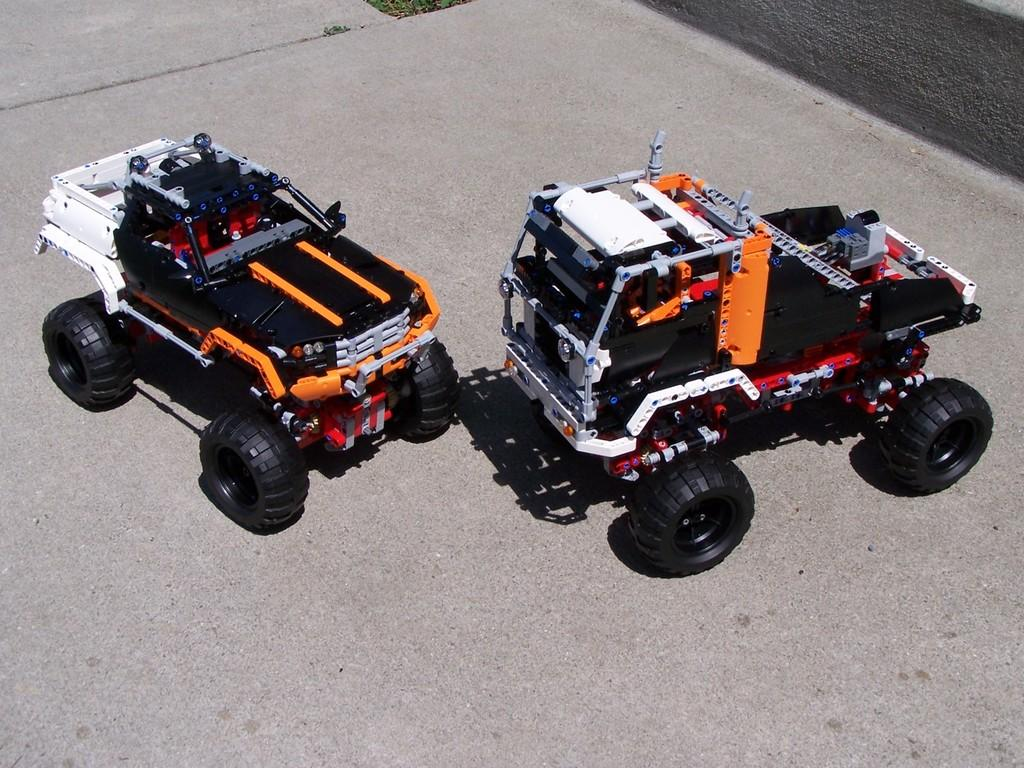What type of objects are on the platform in the image? There are toy vehicles on a platform in the image. What can be seen in the background of the image? There is grass visible in the background of the image. How many lizards can be seen crawling on the toy vehicles in the image? There are no lizards present in the image; it features toy vehicles on a platform. What type of terrain is visible in the image? The image does not show any terrain; it only features a platform with toy vehicles and grass visible in the background. 